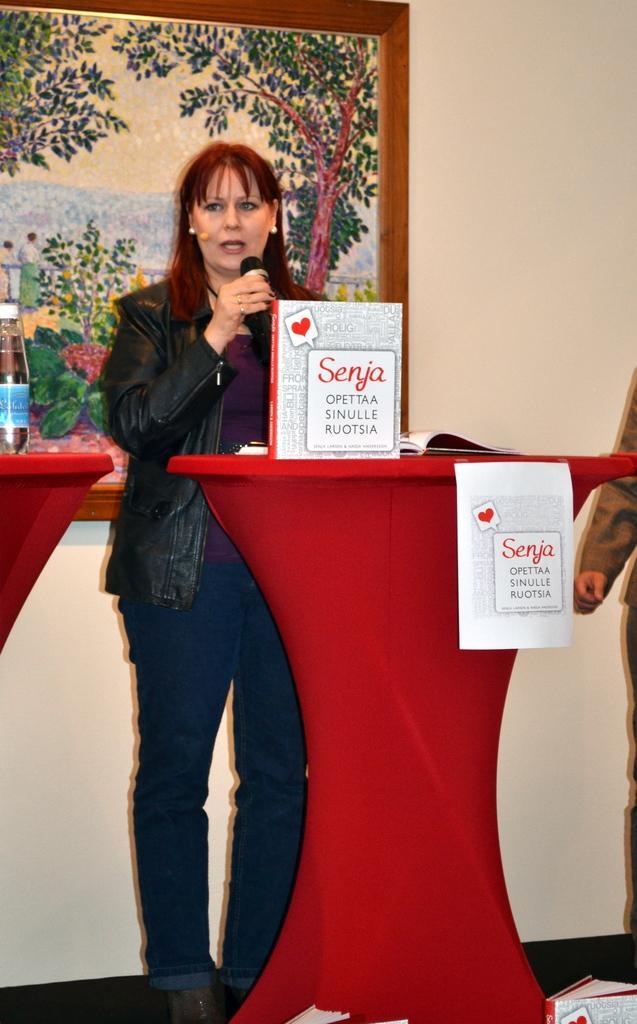Could you give a brief overview of what you see in this image? In this image there is a woman standing and speaking in a mic, in front of the woman on the podium there are some objects, beside the podium there is a person standing, on the podium there are some objects, behind the woman there is a photo frame on the wall. 